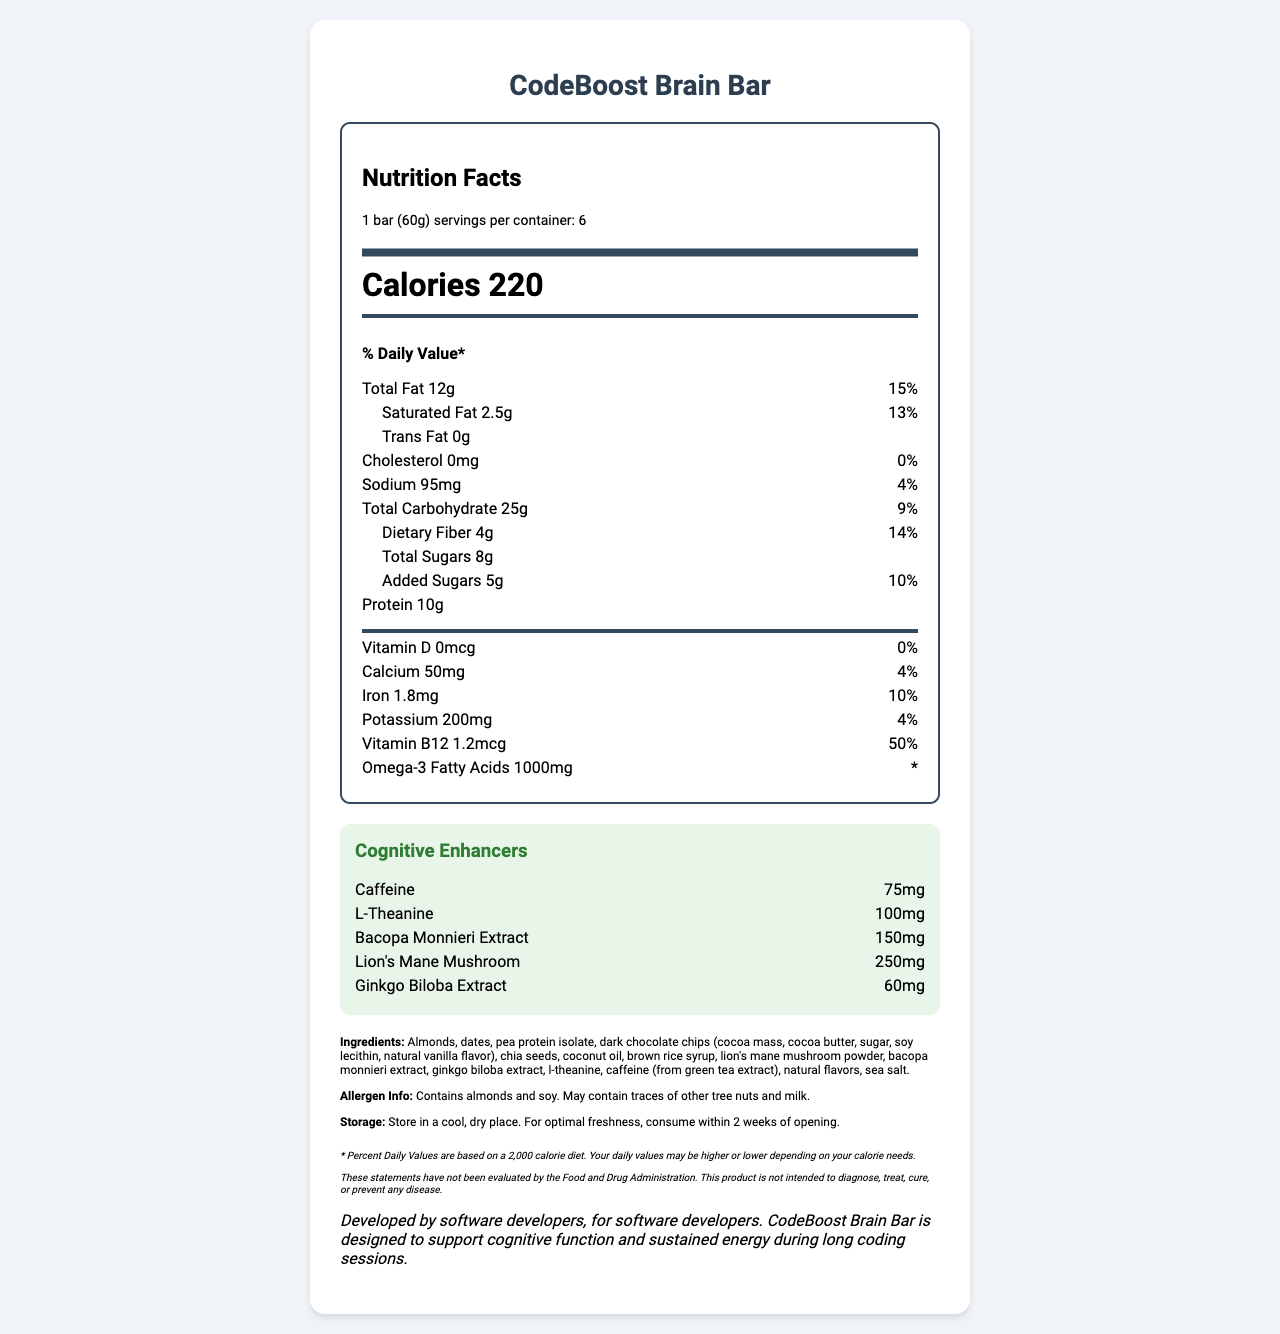what is the product name? The product name is given at the top of the Nutrition Facts Label.
Answer: CodeBoost Brain Bar what is the serving size of the CodeBoost Brain Bar? The serving size is specified as "1 bar (60g)" in the nutrition information.
Answer: 1 bar (60g) how many calories are in one serving of CodeBoost Brain Bar? The number of calories per serving is listed as 220.
Answer: 220 what is the amount of total fat per serving? The total fat per serving is specified as 12g.
Answer: 12g how much protein is in one serving? The protein content per serving is listed as 10g.
Answer: 10g how much omega-3 fatty acid is present in one serving of CodeBoost Brain Bar? The amount of omega-3 fatty acids per serving is listed as 1000mg.
Answer: 1000mg what is the daily value percentage for vitamin B12 per serving? The daily value percentage for vitamin B12 per serving is listed as 50%.
Answer: 50% which ingredient in the CodeBoost Brain Bar is a cognitive enhancer? A. Almonds B. Dates C. Bacopa Monnieri Extract D. Pea Protein Isolate E. Sea Salt The cognitive enhancer Bacopa Monnieri Extract is listed in the cognitive enhancers section and in the ingredients list.
Answer: C what is the amount of caffeine per serving? The amount of caffeine per serving is specified as 75mg.
Answer: 75mg which ingredient contributes to the protein content? A. Almonds B. Pea Protein Isolate C. Dark Chocolate Chips D. Coconut Oil Pea Protein Isolate is the ingredient that contributes to the protein content in the bar.
Answer: B what is the main purpose of CodeBoost Brain Bar as stated by the manufacturer? The manufacturer statement specifies that the product is designed to support cognitive function and sustained energy during long coding sessions.
Answer: To support cognitive function and sustained energy during long coding sessions. does the product contain any allergens? The allergen information specifies that the product contains almonds and soy and may contain traces of other tree nuts and milk.
Answer: Yes can the omega-3 fatty acid daily value be determined from the document? The daily value percentage for omega-3 fatty acids is not provided; it is indicated as "*".
Answer: No what are the storage instructions for CodeBoost Brain Bar? The storage instructions specify to store in a cool, dry place and to consume within 2 weeks of opening for optimal freshness.
Answer: Store in a cool, dry place. For optimal freshness, consume within 2 weeks of opening. how many servings are in one container of CodeBoost Brain Bar? The document states that there are 6 servings per container.
Answer: 6 describe the main idea of the document. The document provides detailed information about the nutritional content, ingredients, and purpose of the CodeBoost Brain Bar, which is aimed at enhancing cognitive function and sustained energy for software developers.
Answer: The document is a Nutrition Facts Label for CodeBoost Brain Bar, detailing serving size, nutritional content, cognitive-enhancing ingredients, allergens, storage instructions, and a manufacturer statement indicating the bar is designed to support cognitive function and energy for software developers. 